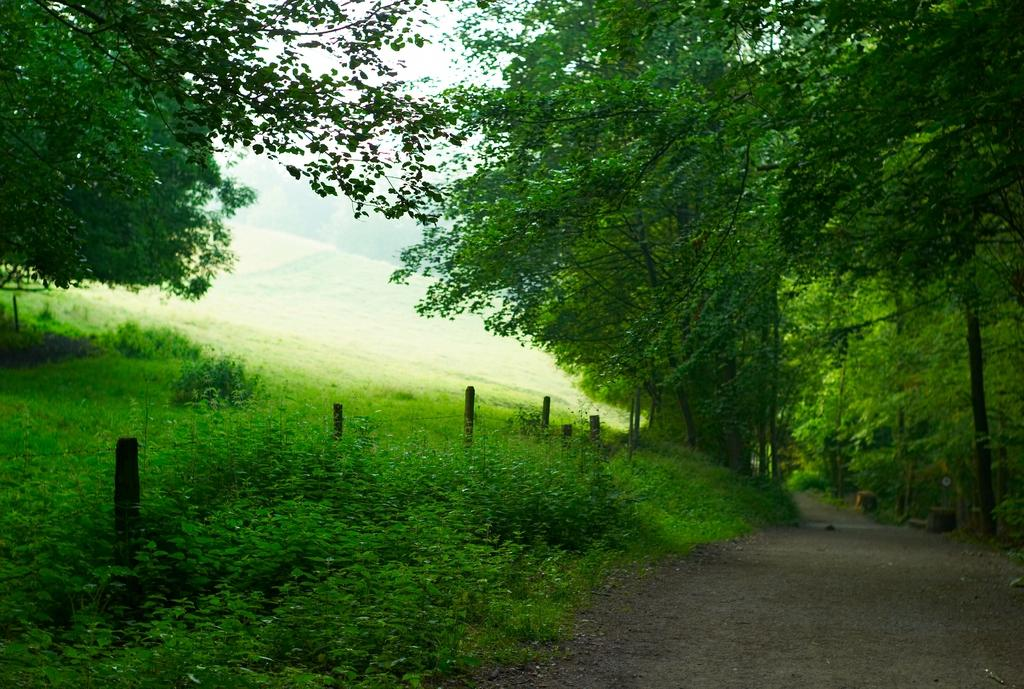What is located at the bottom of the image? There are plants and a road at the bottom of the image. What is visible at the top of the image? The sky is visible at the top of the image. What type of vegetation can be seen in the image? There are trees in the image. Can you see a sponge hanging from the trees in the image? There is no sponge present in the image; it features plants, trees, and a road. Is there a hill visible in the image? There is no hill visible in the image; it features plants, trees, and a road. 